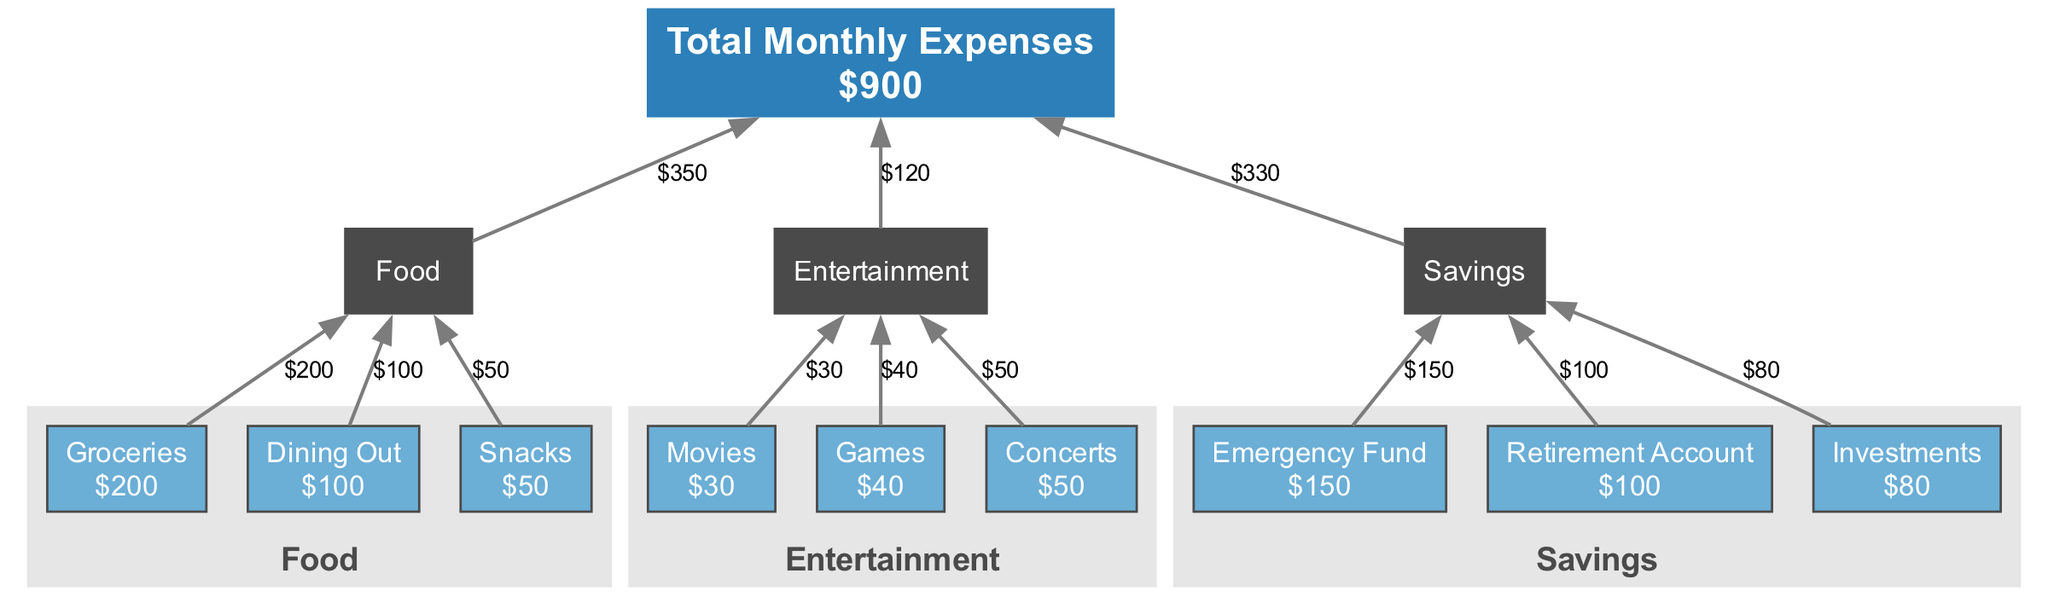What is the total amount spent on food? To find the total amount spent on food, we need to sum all the subcategories under the "Food" category. The subcategories are Groceries ($200), Dining Out ($100), and Snacks ($50). Therefore, the total is calculated as 200 + 100 + 50 = 350.
Answer: 350 How many subcategories are under the Entertainment category? The Entertainment category contains three subcategories: Movies, Games, and Concerts. Therefore, the number of subcategories is 3.
Answer: 3 What is the highest single expense category? To determine the highest single expense category, we compare the total amounts of each category: Food ($350), Entertainment ($120), and Savings ($330). The Food category has the highest total amount.
Answer: Food How much is spent on Dining Out? The amount spent specifically on Dining Out is directly provided in the diagram. According to the expenses listed, Dining Out has a designated amount of $100.
Answer: 100 Which category has the least total expense? We calculate the total expenses for each category: Food ($350), Entertainment ($120), Savings ($330). The category with the least total expense is Entertainment, with a total of $120.
Answer: Entertainment What is the total amount allocated for the Emergency Fund? Looking at the Savings category, the amount designated for the Emergency Fund is explicitly labeled as $150. Therefore, there is no need for further calculation.
Answer: 150 What is the combined total of all subcategory expenses in Savings? For the Savings category, the subcategories are Emergency Fund ($150), Retirement Account ($100), and Investments ($80). We sum these amounts: 150 + 100 + 80 = 330.
Answer: 330 What percentage of total monthly expenses is spent on Games? The expense for Games is $40. To find the percentage of total monthly expenses ($900), we use the formula (40 / 900) * 100, which results in approximately 4.44%.
Answer: 4.44% Which category has a total expense greater than $300? We compare the totals of each category again: Food ($350), Entertainment ($120), Savings ($330). The categories Food and Savings both have total expenses greater than $300.
Answer: Food, Savings 